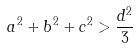Convert formula to latex. <formula><loc_0><loc_0><loc_500><loc_500>a ^ { 2 } + b ^ { 2 } + c ^ { 2 } > \frac { d ^ { 2 } } { 3 }</formula> 